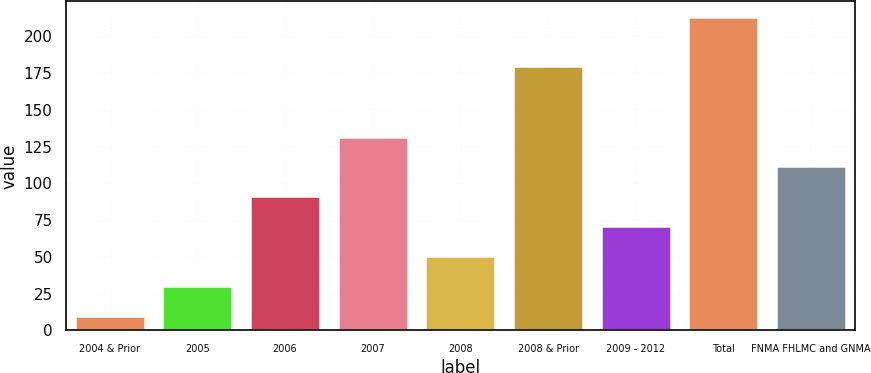<chart> <loc_0><loc_0><loc_500><loc_500><bar_chart><fcel>2004 & Prior<fcel>2005<fcel>2006<fcel>2007<fcel>2008<fcel>2008 & Prior<fcel>2009 - 2012<fcel>Total<fcel>FNMA FHLMC and GNMA<nl><fcel>10<fcel>30.3<fcel>91.2<fcel>131.8<fcel>50.6<fcel>180<fcel>70.9<fcel>213<fcel>111.5<nl></chart> 